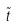<formula> <loc_0><loc_0><loc_500><loc_500>\tilde { t }</formula> 